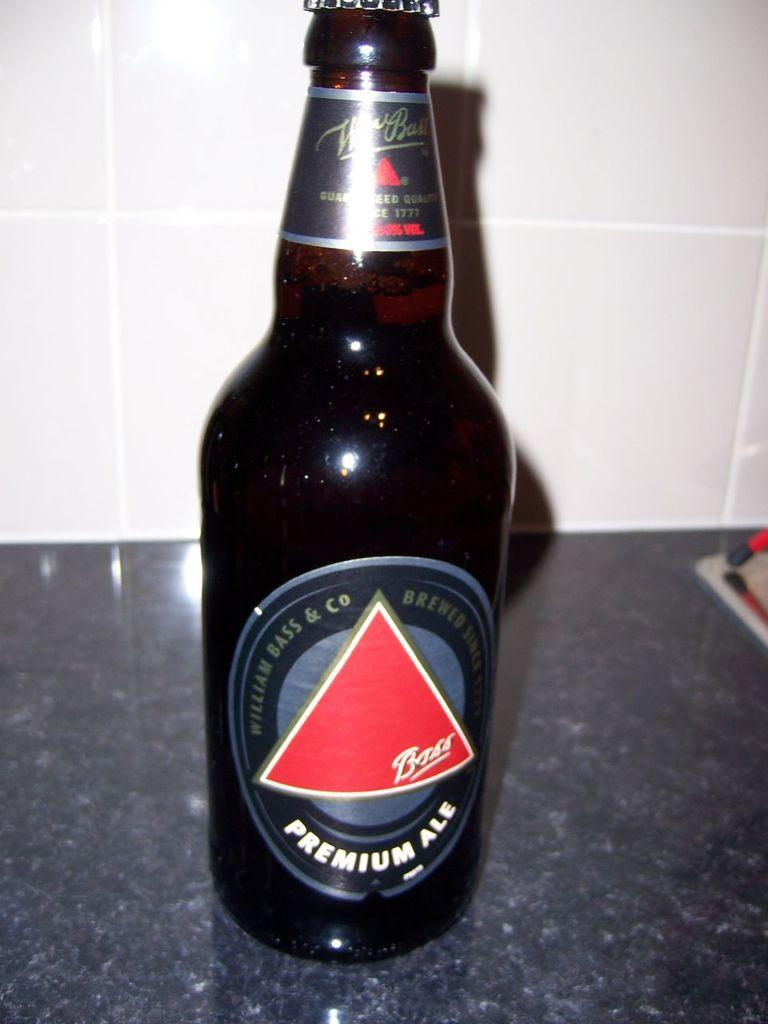Provide a one-sentence caption for the provided image. A bottle of Bass Premium Ale sits on a granite countertop. 